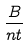Convert formula to latex. <formula><loc_0><loc_0><loc_500><loc_500>\frac { B } { n t }</formula> 